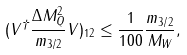<formula> <loc_0><loc_0><loc_500><loc_500>( V ^ { \dagger } \frac { \Delta M _ { Q } ^ { 2 } } { m _ { 3 / 2 } } V ) _ { 1 2 } \leq \frac { 1 } { 1 0 0 } \frac { m _ { 3 / 2 } } { M _ { W } } ,</formula> 